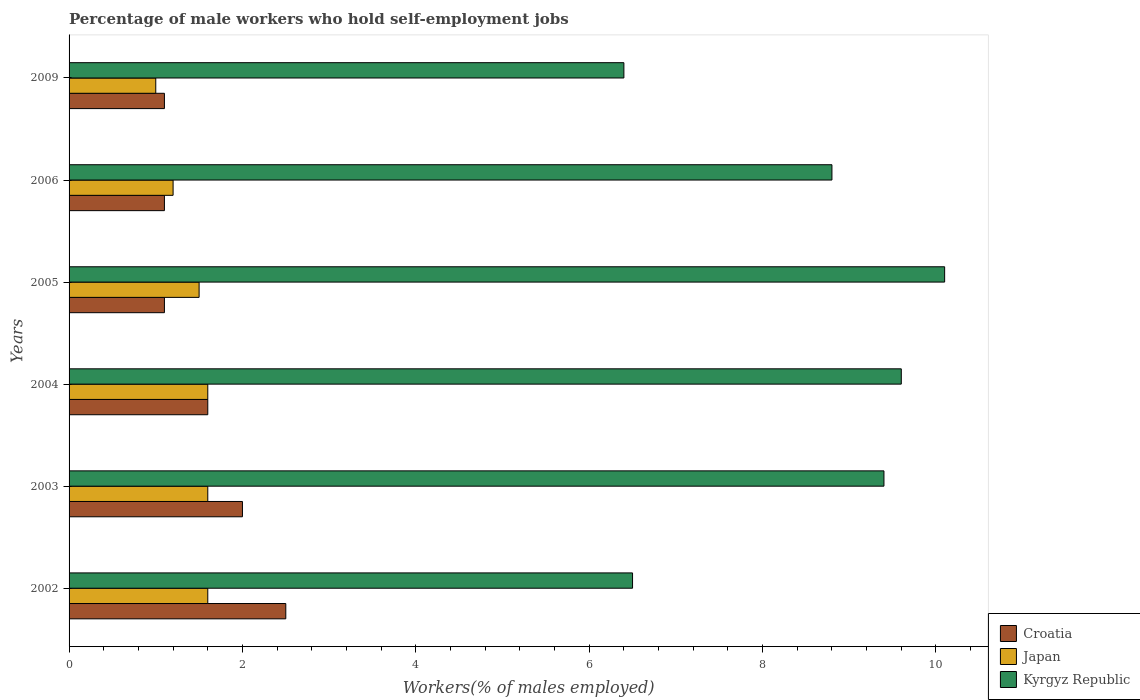How many groups of bars are there?
Offer a terse response. 6. Are the number of bars on each tick of the Y-axis equal?
Make the answer very short. Yes. How many bars are there on the 1st tick from the bottom?
Your answer should be very brief. 3. What is the percentage of self-employed male workers in Japan in 2006?
Your answer should be very brief. 1.2. Across all years, what is the minimum percentage of self-employed male workers in Kyrgyz Republic?
Your response must be concise. 6.4. In which year was the percentage of self-employed male workers in Kyrgyz Republic maximum?
Offer a terse response. 2005. What is the total percentage of self-employed male workers in Croatia in the graph?
Provide a short and direct response. 9.4. What is the difference between the percentage of self-employed male workers in Kyrgyz Republic in 2003 and that in 2006?
Offer a terse response. 0.6. What is the difference between the percentage of self-employed male workers in Croatia in 2003 and the percentage of self-employed male workers in Kyrgyz Republic in 2002?
Keep it short and to the point. -4.5. What is the average percentage of self-employed male workers in Kyrgyz Republic per year?
Provide a succinct answer. 8.47. In the year 2006, what is the difference between the percentage of self-employed male workers in Japan and percentage of self-employed male workers in Kyrgyz Republic?
Ensure brevity in your answer.  -7.6. Is the percentage of self-employed male workers in Kyrgyz Republic in 2002 less than that in 2003?
Offer a terse response. Yes. What is the difference between the highest and the second highest percentage of self-employed male workers in Kyrgyz Republic?
Give a very brief answer. 0.5. What is the difference between the highest and the lowest percentage of self-employed male workers in Croatia?
Your answer should be very brief. 1.4. What does the 1st bar from the top in 2005 represents?
Make the answer very short. Kyrgyz Republic. What does the 1st bar from the bottom in 2009 represents?
Your answer should be very brief. Croatia. Is it the case that in every year, the sum of the percentage of self-employed male workers in Croatia and percentage of self-employed male workers in Japan is greater than the percentage of self-employed male workers in Kyrgyz Republic?
Your answer should be compact. No. How many bars are there?
Provide a succinct answer. 18. Are all the bars in the graph horizontal?
Give a very brief answer. Yes. What is the difference between two consecutive major ticks on the X-axis?
Your response must be concise. 2. How many legend labels are there?
Offer a very short reply. 3. How are the legend labels stacked?
Make the answer very short. Vertical. What is the title of the graph?
Your answer should be very brief. Percentage of male workers who hold self-employment jobs. What is the label or title of the X-axis?
Offer a terse response. Workers(% of males employed). What is the Workers(% of males employed) of Japan in 2002?
Ensure brevity in your answer.  1.6. What is the Workers(% of males employed) in Kyrgyz Republic in 2002?
Your answer should be compact. 6.5. What is the Workers(% of males employed) of Japan in 2003?
Give a very brief answer. 1.6. What is the Workers(% of males employed) of Kyrgyz Republic in 2003?
Your answer should be very brief. 9.4. What is the Workers(% of males employed) of Croatia in 2004?
Your answer should be compact. 1.6. What is the Workers(% of males employed) of Japan in 2004?
Your response must be concise. 1.6. What is the Workers(% of males employed) of Kyrgyz Republic in 2004?
Provide a succinct answer. 9.6. What is the Workers(% of males employed) of Croatia in 2005?
Give a very brief answer. 1.1. What is the Workers(% of males employed) in Kyrgyz Republic in 2005?
Ensure brevity in your answer.  10.1. What is the Workers(% of males employed) of Croatia in 2006?
Offer a terse response. 1.1. What is the Workers(% of males employed) of Japan in 2006?
Offer a terse response. 1.2. What is the Workers(% of males employed) of Kyrgyz Republic in 2006?
Ensure brevity in your answer.  8.8. What is the Workers(% of males employed) of Croatia in 2009?
Your answer should be compact. 1.1. What is the Workers(% of males employed) of Japan in 2009?
Your response must be concise. 1. What is the Workers(% of males employed) in Kyrgyz Republic in 2009?
Offer a very short reply. 6.4. Across all years, what is the maximum Workers(% of males employed) in Japan?
Keep it short and to the point. 1.6. Across all years, what is the maximum Workers(% of males employed) in Kyrgyz Republic?
Ensure brevity in your answer.  10.1. Across all years, what is the minimum Workers(% of males employed) of Croatia?
Make the answer very short. 1.1. Across all years, what is the minimum Workers(% of males employed) of Kyrgyz Republic?
Your answer should be very brief. 6.4. What is the total Workers(% of males employed) of Kyrgyz Republic in the graph?
Your answer should be compact. 50.8. What is the difference between the Workers(% of males employed) in Japan in 2002 and that in 2003?
Give a very brief answer. 0. What is the difference between the Workers(% of males employed) of Kyrgyz Republic in 2002 and that in 2003?
Offer a terse response. -2.9. What is the difference between the Workers(% of males employed) in Croatia in 2002 and that in 2004?
Provide a short and direct response. 0.9. What is the difference between the Workers(% of males employed) of Kyrgyz Republic in 2002 and that in 2004?
Your answer should be very brief. -3.1. What is the difference between the Workers(% of males employed) in Japan in 2002 and that in 2005?
Keep it short and to the point. 0.1. What is the difference between the Workers(% of males employed) of Japan in 2002 and that in 2006?
Provide a short and direct response. 0.4. What is the difference between the Workers(% of males employed) in Japan in 2003 and that in 2004?
Your response must be concise. 0. What is the difference between the Workers(% of males employed) of Kyrgyz Republic in 2003 and that in 2004?
Your answer should be very brief. -0.2. What is the difference between the Workers(% of males employed) in Kyrgyz Republic in 2003 and that in 2005?
Offer a very short reply. -0.7. What is the difference between the Workers(% of males employed) of Croatia in 2003 and that in 2006?
Keep it short and to the point. 0.9. What is the difference between the Workers(% of males employed) in Japan in 2003 and that in 2006?
Ensure brevity in your answer.  0.4. What is the difference between the Workers(% of males employed) in Kyrgyz Republic in 2003 and that in 2006?
Your answer should be very brief. 0.6. What is the difference between the Workers(% of males employed) of Kyrgyz Republic in 2003 and that in 2009?
Make the answer very short. 3. What is the difference between the Workers(% of males employed) in Japan in 2004 and that in 2005?
Provide a short and direct response. 0.1. What is the difference between the Workers(% of males employed) in Kyrgyz Republic in 2004 and that in 2005?
Provide a succinct answer. -0.5. What is the difference between the Workers(% of males employed) of Croatia in 2004 and that in 2006?
Your answer should be compact. 0.5. What is the difference between the Workers(% of males employed) in Croatia in 2004 and that in 2009?
Make the answer very short. 0.5. What is the difference between the Workers(% of males employed) in Kyrgyz Republic in 2004 and that in 2009?
Your answer should be very brief. 3.2. What is the difference between the Workers(% of males employed) of Japan in 2005 and that in 2006?
Provide a succinct answer. 0.3. What is the difference between the Workers(% of males employed) in Kyrgyz Republic in 2005 and that in 2006?
Keep it short and to the point. 1.3. What is the difference between the Workers(% of males employed) of Croatia in 2005 and that in 2009?
Keep it short and to the point. 0. What is the difference between the Workers(% of males employed) in Kyrgyz Republic in 2005 and that in 2009?
Give a very brief answer. 3.7. What is the difference between the Workers(% of males employed) in Croatia in 2006 and that in 2009?
Your answer should be compact. 0. What is the difference between the Workers(% of males employed) in Japan in 2006 and that in 2009?
Provide a short and direct response. 0.2. What is the difference between the Workers(% of males employed) of Croatia in 2002 and the Workers(% of males employed) of Kyrgyz Republic in 2004?
Offer a terse response. -7.1. What is the difference between the Workers(% of males employed) in Croatia in 2002 and the Workers(% of males employed) in Japan in 2005?
Your answer should be very brief. 1. What is the difference between the Workers(% of males employed) in Croatia in 2002 and the Workers(% of males employed) in Kyrgyz Republic in 2005?
Your answer should be very brief. -7.6. What is the difference between the Workers(% of males employed) in Japan in 2002 and the Workers(% of males employed) in Kyrgyz Republic in 2005?
Give a very brief answer. -8.5. What is the difference between the Workers(% of males employed) of Japan in 2002 and the Workers(% of males employed) of Kyrgyz Republic in 2006?
Give a very brief answer. -7.2. What is the difference between the Workers(% of males employed) in Japan in 2002 and the Workers(% of males employed) in Kyrgyz Republic in 2009?
Keep it short and to the point. -4.8. What is the difference between the Workers(% of males employed) of Croatia in 2003 and the Workers(% of males employed) of Kyrgyz Republic in 2004?
Provide a short and direct response. -7.6. What is the difference between the Workers(% of males employed) in Japan in 2003 and the Workers(% of males employed) in Kyrgyz Republic in 2004?
Provide a short and direct response. -8. What is the difference between the Workers(% of males employed) of Japan in 2003 and the Workers(% of males employed) of Kyrgyz Republic in 2005?
Provide a succinct answer. -8.5. What is the difference between the Workers(% of males employed) in Croatia in 2003 and the Workers(% of males employed) in Japan in 2006?
Offer a terse response. 0.8. What is the difference between the Workers(% of males employed) of Croatia in 2003 and the Workers(% of males employed) of Japan in 2009?
Provide a succinct answer. 1. What is the difference between the Workers(% of males employed) of Croatia in 2003 and the Workers(% of males employed) of Kyrgyz Republic in 2009?
Make the answer very short. -4.4. What is the difference between the Workers(% of males employed) in Croatia in 2004 and the Workers(% of males employed) in Kyrgyz Republic in 2005?
Provide a succinct answer. -8.5. What is the difference between the Workers(% of males employed) of Croatia in 2004 and the Workers(% of males employed) of Kyrgyz Republic in 2009?
Your answer should be very brief. -4.8. What is the difference between the Workers(% of males employed) in Croatia in 2005 and the Workers(% of males employed) in Japan in 2006?
Keep it short and to the point. -0.1. What is the difference between the Workers(% of males employed) of Croatia in 2005 and the Workers(% of males employed) of Kyrgyz Republic in 2006?
Offer a very short reply. -7.7. What is the difference between the Workers(% of males employed) of Croatia in 2005 and the Workers(% of males employed) of Kyrgyz Republic in 2009?
Your answer should be very brief. -5.3. What is the difference between the Workers(% of males employed) of Japan in 2005 and the Workers(% of males employed) of Kyrgyz Republic in 2009?
Provide a short and direct response. -4.9. What is the difference between the Workers(% of males employed) of Croatia in 2006 and the Workers(% of males employed) of Kyrgyz Republic in 2009?
Your response must be concise. -5.3. What is the average Workers(% of males employed) of Croatia per year?
Your answer should be compact. 1.57. What is the average Workers(% of males employed) of Japan per year?
Your answer should be compact. 1.42. What is the average Workers(% of males employed) of Kyrgyz Republic per year?
Your answer should be very brief. 8.47. In the year 2002, what is the difference between the Workers(% of males employed) in Croatia and Workers(% of males employed) in Japan?
Ensure brevity in your answer.  0.9. In the year 2002, what is the difference between the Workers(% of males employed) in Croatia and Workers(% of males employed) in Kyrgyz Republic?
Your response must be concise. -4. In the year 2002, what is the difference between the Workers(% of males employed) of Japan and Workers(% of males employed) of Kyrgyz Republic?
Make the answer very short. -4.9. In the year 2003, what is the difference between the Workers(% of males employed) in Croatia and Workers(% of males employed) in Japan?
Your answer should be very brief. 0.4. In the year 2003, what is the difference between the Workers(% of males employed) of Croatia and Workers(% of males employed) of Kyrgyz Republic?
Give a very brief answer. -7.4. In the year 2003, what is the difference between the Workers(% of males employed) in Japan and Workers(% of males employed) in Kyrgyz Republic?
Keep it short and to the point. -7.8. In the year 2004, what is the difference between the Workers(% of males employed) in Croatia and Workers(% of males employed) in Kyrgyz Republic?
Your answer should be compact. -8. In the year 2004, what is the difference between the Workers(% of males employed) of Japan and Workers(% of males employed) of Kyrgyz Republic?
Offer a terse response. -8. In the year 2005, what is the difference between the Workers(% of males employed) in Croatia and Workers(% of males employed) in Japan?
Provide a short and direct response. -0.4. In the year 2005, what is the difference between the Workers(% of males employed) in Croatia and Workers(% of males employed) in Kyrgyz Republic?
Make the answer very short. -9. In the year 2006, what is the difference between the Workers(% of males employed) of Croatia and Workers(% of males employed) of Japan?
Provide a succinct answer. -0.1. In the year 2006, what is the difference between the Workers(% of males employed) in Japan and Workers(% of males employed) in Kyrgyz Republic?
Ensure brevity in your answer.  -7.6. In the year 2009, what is the difference between the Workers(% of males employed) in Croatia and Workers(% of males employed) in Japan?
Your response must be concise. 0.1. In the year 2009, what is the difference between the Workers(% of males employed) of Croatia and Workers(% of males employed) of Kyrgyz Republic?
Make the answer very short. -5.3. What is the ratio of the Workers(% of males employed) of Croatia in 2002 to that in 2003?
Keep it short and to the point. 1.25. What is the ratio of the Workers(% of males employed) in Japan in 2002 to that in 2003?
Your response must be concise. 1. What is the ratio of the Workers(% of males employed) of Kyrgyz Republic in 2002 to that in 2003?
Provide a succinct answer. 0.69. What is the ratio of the Workers(% of males employed) of Croatia in 2002 to that in 2004?
Provide a succinct answer. 1.56. What is the ratio of the Workers(% of males employed) of Kyrgyz Republic in 2002 to that in 2004?
Offer a terse response. 0.68. What is the ratio of the Workers(% of males employed) of Croatia in 2002 to that in 2005?
Ensure brevity in your answer.  2.27. What is the ratio of the Workers(% of males employed) in Japan in 2002 to that in 2005?
Offer a terse response. 1.07. What is the ratio of the Workers(% of males employed) of Kyrgyz Republic in 2002 to that in 2005?
Give a very brief answer. 0.64. What is the ratio of the Workers(% of males employed) of Croatia in 2002 to that in 2006?
Your response must be concise. 2.27. What is the ratio of the Workers(% of males employed) of Kyrgyz Republic in 2002 to that in 2006?
Offer a terse response. 0.74. What is the ratio of the Workers(% of males employed) in Croatia in 2002 to that in 2009?
Your answer should be very brief. 2.27. What is the ratio of the Workers(% of males employed) of Kyrgyz Republic in 2002 to that in 2009?
Offer a very short reply. 1.02. What is the ratio of the Workers(% of males employed) in Croatia in 2003 to that in 2004?
Ensure brevity in your answer.  1.25. What is the ratio of the Workers(% of males employed) of Kyrgyz Republic in 2003 to that in 2004?
Provide a short and direct response. 0.98. What is the ratio of the Workers(% of males employed) in Croatia in 2003 to that in 2005?
Ensure brevity in your answer.  1.82. What is the ratio of the Workers(% of males employed) in Japan in 2003 to that in 2005?
Give a very brief answer. 1.07. What is the ratio of the Workers(% of males employed) in Kyrgyz Republic in 2003 to that in 2005?
Provide a short and direct response. 0.93. What is the ratio of the Workers(% of males employed) of Croatia in 2003 to that in 2006?
Keep it short and to the point. 1.82. What is the ratio of the Workers(% of males employed) in Japan in 2003 to that in 2006?
Your response must be concise. 1.33. What is the ratio of the Workers(% of males employed) in Kyrgyz Republic in 2003 to that in 2006?
Keep it short and to the point. 1.07. What is the ratio of the Workers(% of males employed) of Croatia in 2003 to that in 2009?
Keep it short and to the point. 1.82. What is the ratio of the Workers(% of males employed) of Kyrgyz Republic in 2003 to that in 2009?
Provide a succinct answer. 1.47. What is the ratio of the Workers(% of males employed) in Croatia in 2004 to that in 2005?
Offer a terse response. 1.45. What is the ratio of the Workers(% of males employed) in Japan in 2004 to that in 2005?
Offer a terse response. 1.07. What is the ratio of the Workers(% of males employed) in Kyrgyz Republic in 2004 to that in 2005?
Give a very brief answer. 0.95. What is the ratio of the Workers(% of males employed) in Croatia in 2004 to that in 2006?
Provide a succinct answer. 1.45. What is the ratio of the Workers(% of males employed) of Japan in 2004 to that in 2006?
Keep it short and to the point. 1.33. What is the ratio of the Workers(% of males employed) of Kyrgyz Republic in 2004 to that in 2006?
Make the answer very short. 1.09. What is the ratio of the Workers(% of males employed) of Croatia in 2004 to that in 2009?
Give a very brief answer. 1.45. What is the ratio of the Workers(% of males employed) of Kyrgyz Republic in 2004 to that in 2009?
Offer a very short reply. 1.5. What is the ratio of the Workers(% of males employed) in Croatia in 2005 to that in 2006?
Provide a succinct answer. 1. What is the ratio of the Workers(% of males employed) in Japan in 2005 to that in 2006?
Ensure brevity in your answer.  1.25. What is the ratio of the Workers(% of males employed) of Kyrgyz Republic in 2005 to that in 2006?
Provide a short and direct response. 1.15. What is the ratio of the Workers(% of males employed) of Croatia in 2005 to that in 2009?
Give a very brief answer. 1. What is the ratio of the Workers(% of males employed) in Japan in 2005 to that in 2009?
Offer a terse response. 1.5. What is the ratio of the Workers(% of males employed) of Kyrgyz Republic in 2005 to that in 2009?
Provide a succinct answer. 1.58. What is the ratio of the Workers(% of males employed) in Croatia in 2006 to that in 2009?
Ensure brevity in your answer.  1. What is the ratio of the Workers(% of males employed) of Kyrgyz Republic in 2006 to that in 2009?
Your answer should be very brief. 1.38. What is the difference between the highest and the second highest Workers(% of males employed) of Croatia?
Your answer should be very brief. 0.5. 